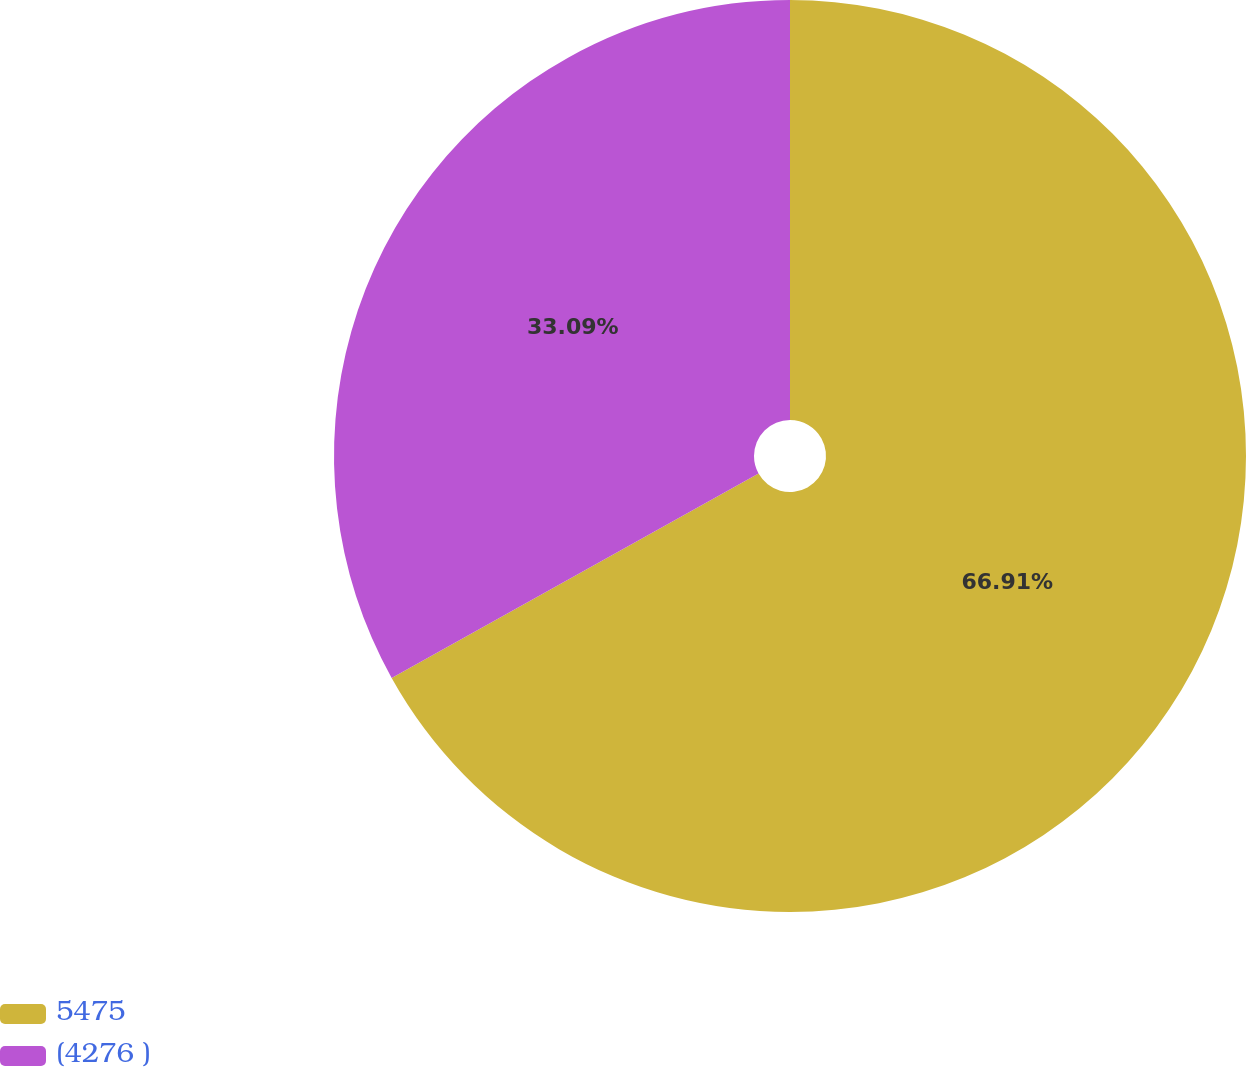Convert chart to OTSL. <chart><loc_0><loc_0><loc_500><loc_500><pie_chart><fcel>5475<fcel>(4276 )<nl><fcel>66.91%<fcel>33.09%<nl></chart> 